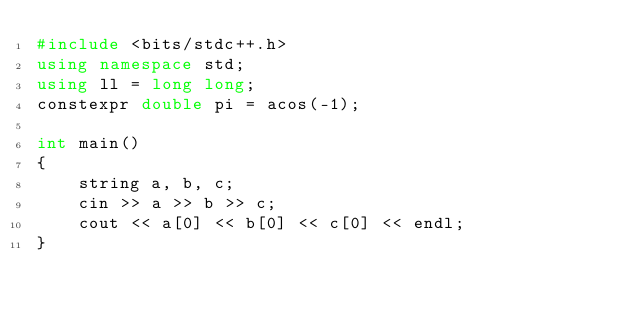<code> <loc_0><loc_0><loc_500><loc_500><_C++_>#include <bits/stdc++.h>
using namespace std;
using ll = long long;
constexpr double pi = acos(-1);

int main()
{
    string a, b, c;
    cin >> a >> b >> c;
    cout << a[0] << b[0] << c[0] << endl;
}

</code> 